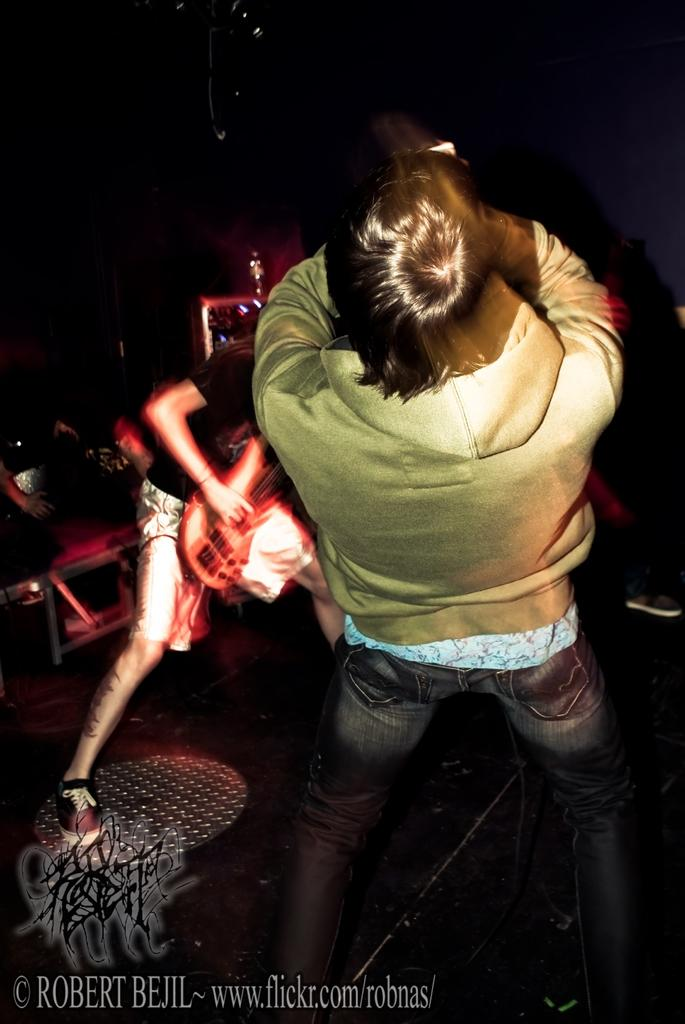Who is the main subject in the image? There is a person in the image. What is the person wearing? The person is wearing a green jacket. What is the person doing in the image? The person is bending backwards and playing a guitar. What nation is the person representing in the image? There is no indication in the image that the person is representing a specific nation. How many legs does the person have in the image? The person has two legs, as is typical for humans. 